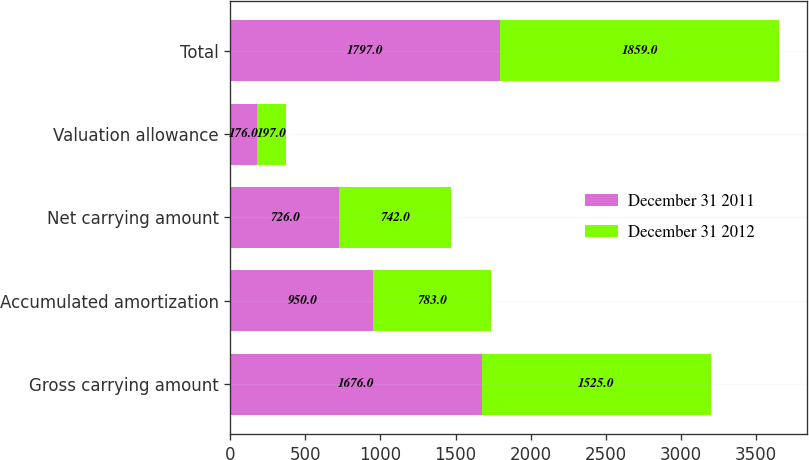<chart> <loc_0><loc_0><loc_500><loc_500><stacked_bar_chart><ecel><fcel>Gross carrying amount<fcel>Accumulated amortization<fcel>Net carrying amount<fcel>Valuation allowance<fcel>Total<nl><fcel>December 31 2011<fcel>1676<fcel>950<fcel>726<fcel>176<fcel>1797<nl><fcel>December 31 2012<fcel>1525<fcel>783<fcel>742<fcel>197<fcel>1859<nl></chart> 